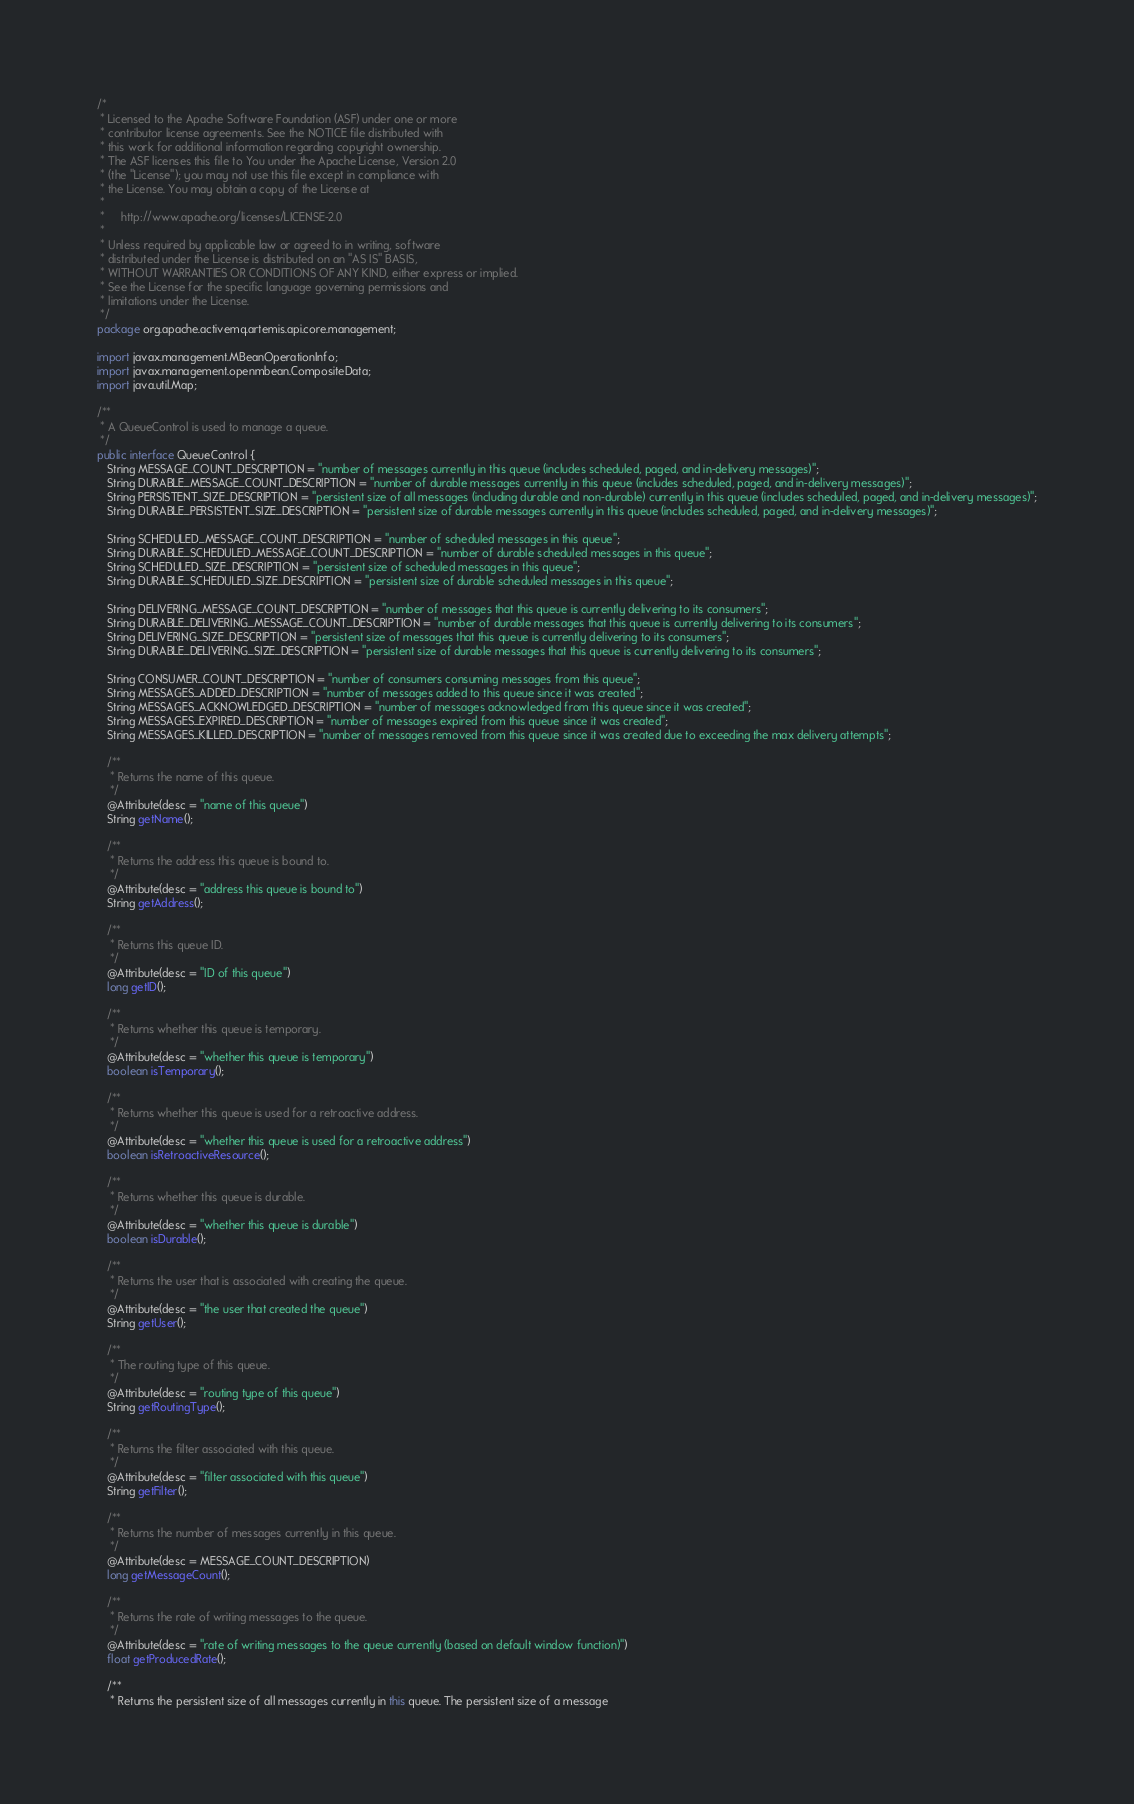<code> <loc_0><loc_0><loc_500><loc_500><_Java_>/*
 * Licensed to the Apache Software Foundation (ASF) under one or more
 * contributor license agreements. See the NOTICE file distributed with
 * this work for additional information regarding copyright ownership.
 * The ASF licenses this file to You under the Apache License, Version 2.0
 * (the "License"); you may not use this file except in compliance with
 * the License. You may obtain a copy of the License at
 *
 *     http://www.apache.org/licenses/LICENSE-2.0
 *
 * Unless required by applicable law or agreed to in writing, software
 * distributed under the License is distributed on an "AS IS" BASIS,
 * WITHOUT WARRANTIES OR CONDITIONS OF ANY KIND, either express or implied.
 * See the License for the specific language governing permissions and
 * limitations under the License.
 */
package org.apache.activemq.artemis.api.core.management;

import javax.management.MBeanOperationInfo;
import javax.management.openmbean.CompositeData;
import java.util.Map;

/**
 * A QueueControl is used to manage a queue.
 */
public interface QueueControl {
   String MESSAGE_COUNT_DESCRIPTION = "number of messages currently in this queue (includes scheduled, paged, and in-delivery messages)";
   String DURABLE_MESSAGE_COUNT_DESCRIPTION = "number of durable messages currently in this queue (includes scheduled, paged, and in-delivery messages)";
   String PERSISTENT_SIZE_DESCRIPTION = "persistent size of all messages (including durable and non-durable) currently in this queue (includes scheduled, paged, and in-delivery messages)";
   String DURABLE_PERSISTENT_SIZE_DESCRIPTION = "persistent size of durable messages currently in this queue (includes scheduled, paged, and in-delivery messages)";

   String SCHEDULED_MESSAGE_COUNT_DESCRIPTION = "number of scheduled messages in this queue";
   String DURABLE_SCHEDULED_MESSAGE_COUNT_DESCRIPTION = "number of durable scheduled messages in this queue";
   String SCHEDULED_SIZE_DESCRIPTION = "persistent size of scheduled messages in this queue";
   String DURABLE_SCHEDULED_SIZE_DESCRIPTION = "persistent size of durable scheduled messages in this queue";

   String DELIVERING_MESSAGE_COUNT_DESCRIPTION = "number of messages that this queue is currently delivering to its consumers";
   String DURABLE_DELIVERING_MESSAGE_COUNT_DESCRIPTION = "number of durable messages that this queue is currently delivering to its consumers";
   String DELIVERING_SIZE_DESCRIPTION = "persistent size of messages that this queue is currently delivering to its consumers";
   String DURABLE_DELIVERING_SIZE_DESCRIPTION = "persistent size of durable messages that this queue is currently delivering to its consumers";

   String CONSUMER_COUNT_DESCRIPTION = "number of consumers consuming messages from this queue";
   String MESSAGES_ADDED_DESCRIPTION = "number of messages added to this queue since it was created";
   String MESSAGES_ACKNOWLEDGED_DESCRIPTION = "number of messages acknowledged from this queue since it was created";
   String MESSAGES_EXPIRED_DESCRIPTION = "number of messages expired from this queue since it was created";
   String MESSAGES_KILLED_DESCRIPTION = "number of messages removed from this queue since it was created due to exceeding the max delivery attempts";

   /**
    * Returns the name of this queue.
    */
   @Attribute(desc = "name of this queue")
   String getName();

   /**
    * Returns the address this queue is bound to.
    */
   @Attribute(desc = "address this queue is bound to")
   String getAddress();

   /**
    * Returns this queue ID.
    */
   @Attribute(desc = "ID of this queue")
   long getID();

   /**
    * Returns whether this queue is temporary.
    */
   @Attribute(desc = "whether this queue is temporary")
   boolean isTemporary();

   /**
    * Returns whether this queue is used for a retroactive address.
    */
   @Attribute(desc = "whether this queue is used for a retroactive address")
   boolean isRetroactiveResource();

   /**
    * Returns whether this queue is durable.
    */
   @Attribute(desc = "whether this queue is durable")
   boolean isDurable();

   /**
    * Returns the user that is associated with creating the queue.
    */
   @Attribute(desc = "the user that created the queue")
   String getUser();

   /**
    * The routing type of this queue.
    */
   @Attribute(desc = "routing type of this queue")
   String getRoutingType();

   /**
    * Returns the filter associated with this queue.
    */
   @Attribute(desc = "filter associated with this queue")
   String getFilter();

   /**
    * Returns the number of messages currently in this queue.
    */
   @Attribute(desc = MESSAGE_COUNT_DESCRIPTION)
   long getMessageCount();

   /**
    * Returns the rate of writing messages to the queue.
    */
   @Attribute(desc = "rate of writing messages to the queue currently (based on default window function)")
   float getProducedRate();

   /**
    * Returns the persistent size of all messages currently in this queue. The persistent size of a message</code> 